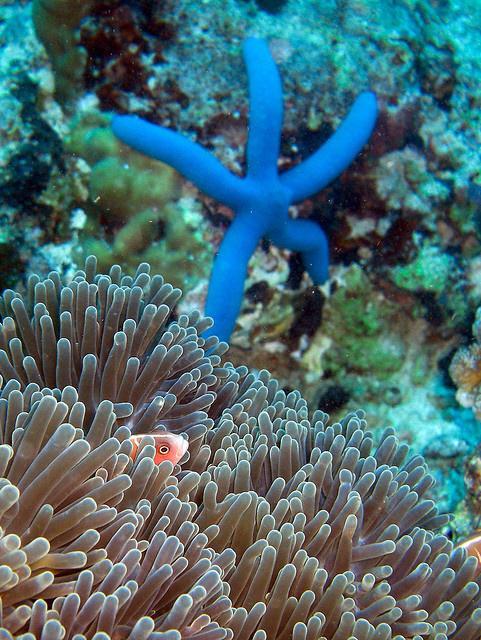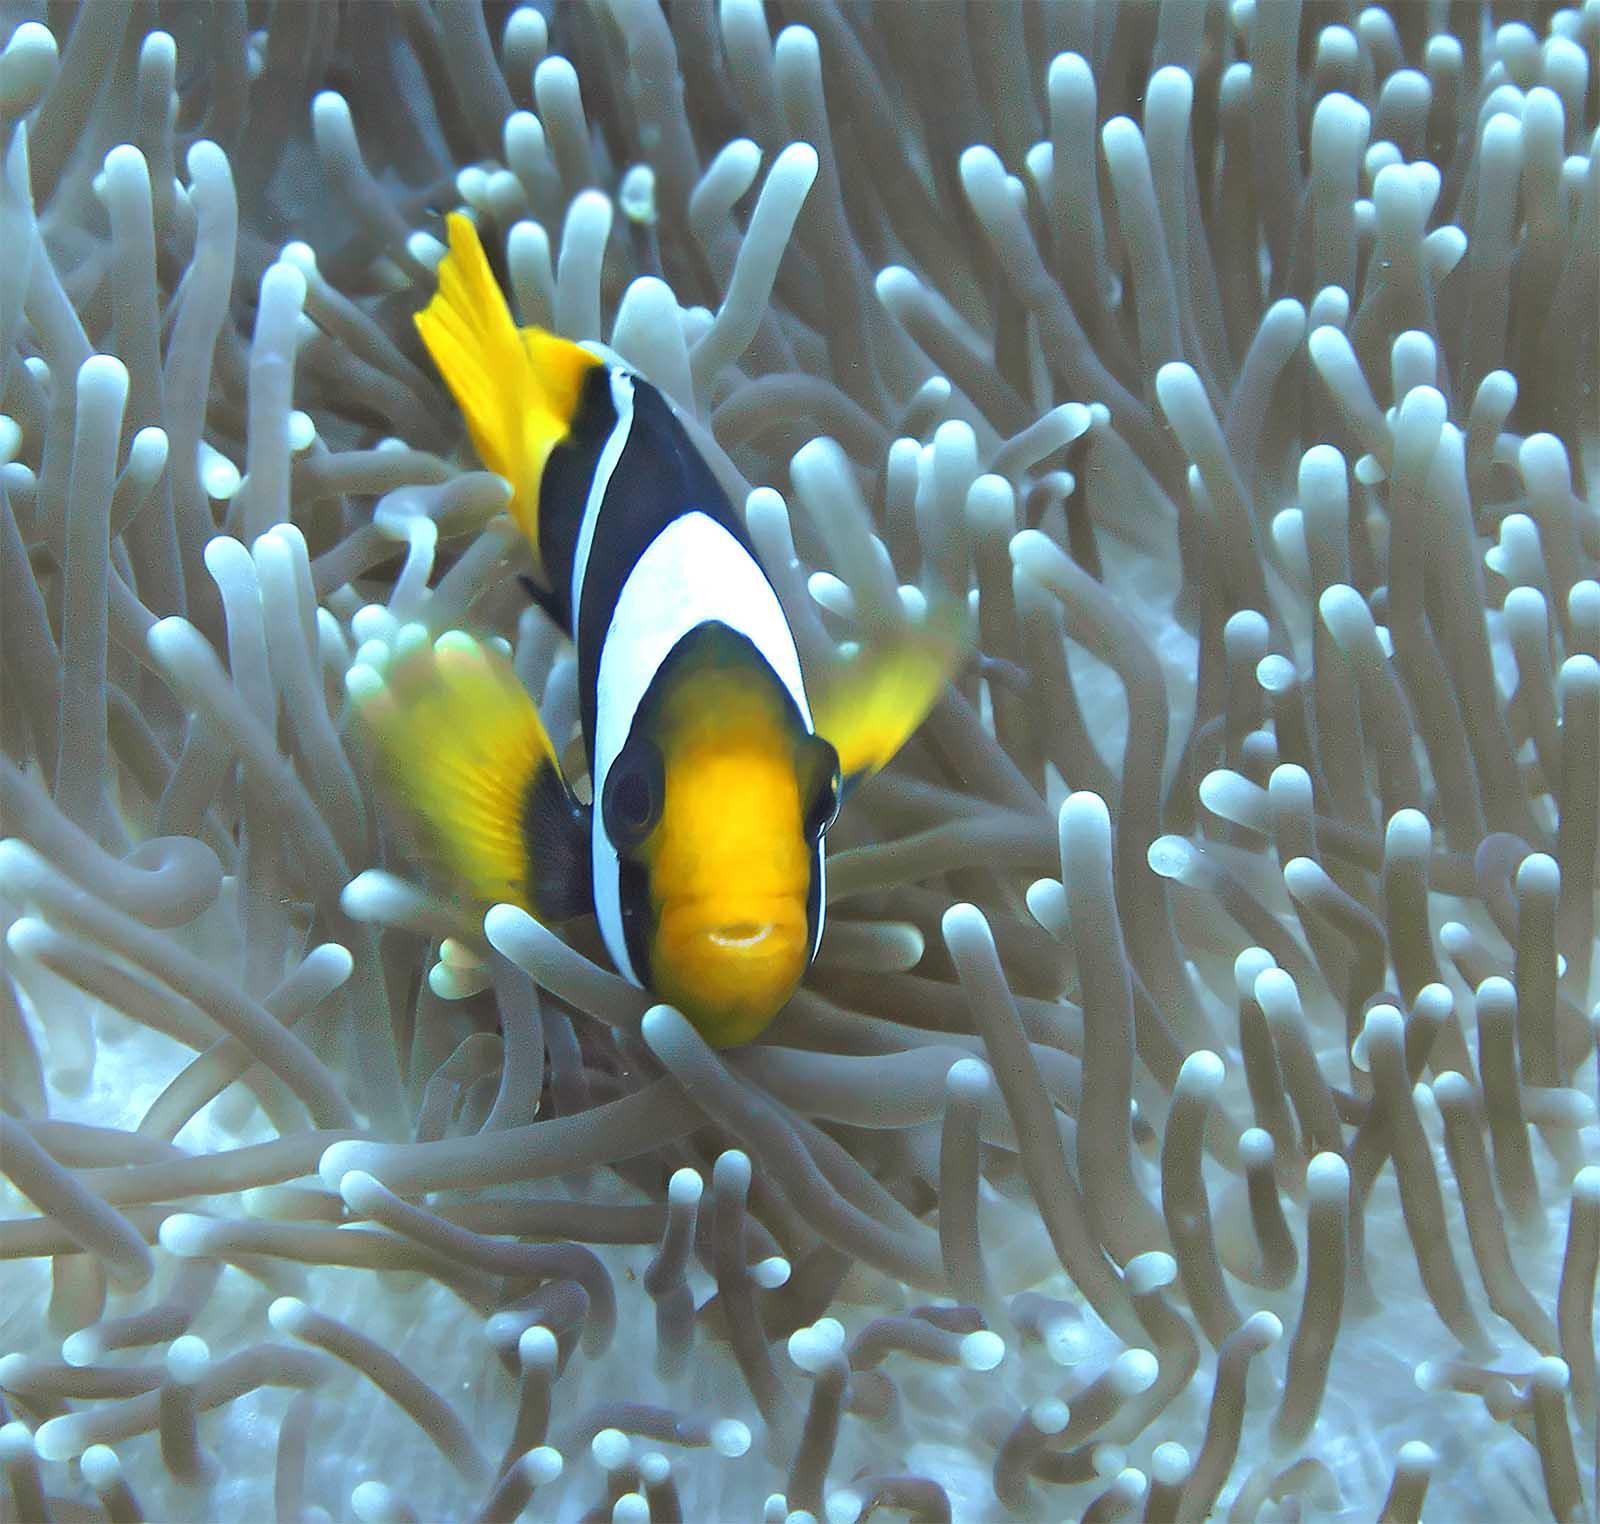The first image is the image on the left, the second image is the image on the right. Considering the images on both sides, is "The left image shows exactly two clown fish close together over anemone, and the right image includes a clown fish over white anemone tendrils." valid? Answer yes or no. No. The first image is the image on the left, the second image is the image on the right. Considering the images on both sides, is "The left and right image contains the same number of fish." valid? Answer yes or no. Yes. 